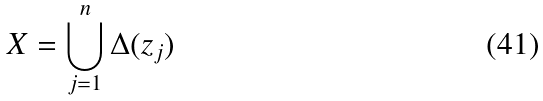Convert formula to latex. <formula><loc_0><loc_0><loc_500><loc_500>X = \bigcup _ { j = 1 } ^ { n } \Delta ( z _ { j } )</formula> 